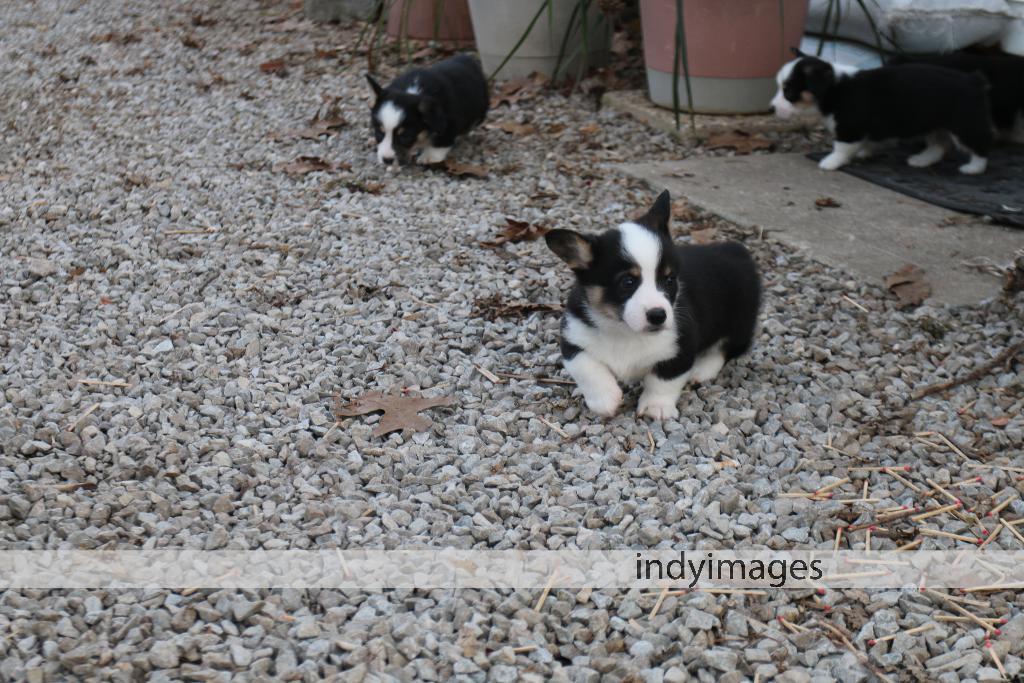Please provide a concise description of this image. In this image I can see few black and white colour puppies. I can also see number of stones, matchsticks and here I can see watermark. 